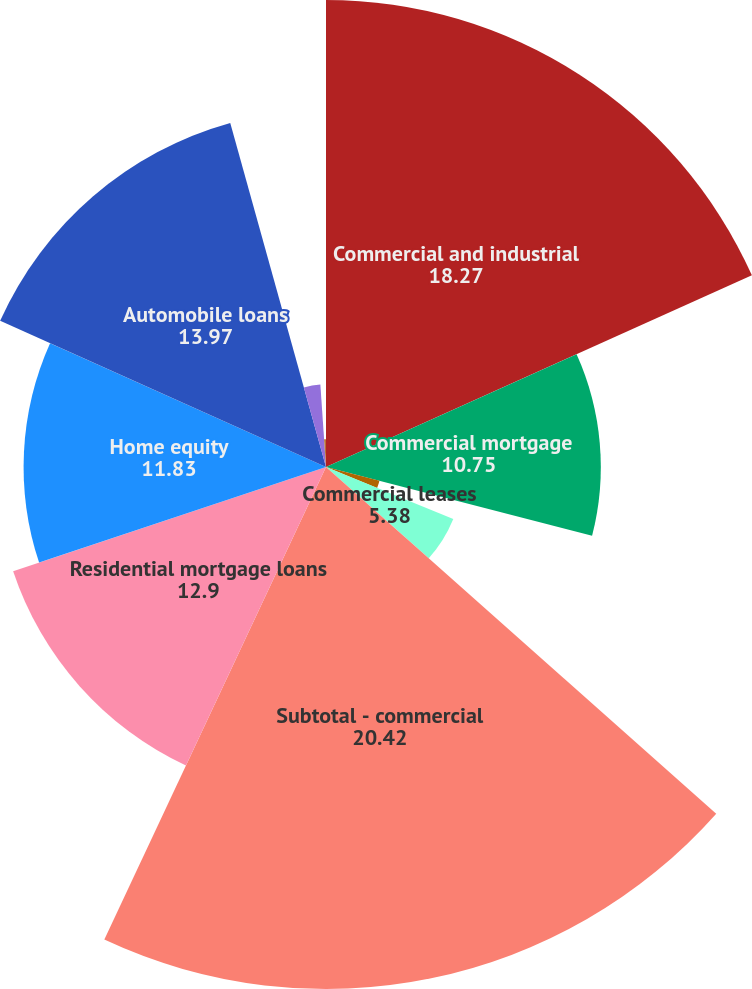Convert chart to OTSL. <chart><loc_0><loc_0><loc_500><loc_500><pie_chart><fcel>Commercial and industrial<fcel>Commercial mortgage<fcel>Commercial construction<fcel>Commercial leases<fcel>Subtotal - commercial<fcel>Residential mortgage loans<fcel>Home equity<fcel>Automobile loans<fcel>Credit card<fcel>Other consumer loans/leases<nl><fcel>18.27%<fcel>10.75%<fcel>2.16%<fcel>5.38%<fcel>20.42%<fcel>12.9%<fcel>11.83%<fcel>13.97%<fcel>3.23%<fcel>1.09%<nl></chart> 